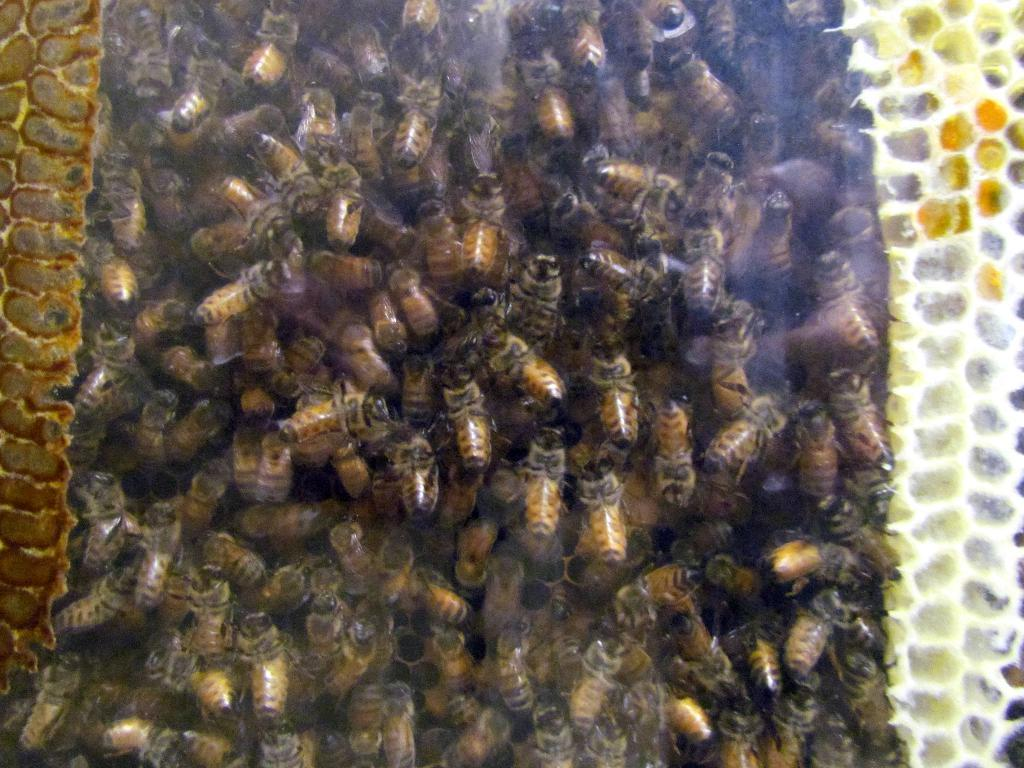What type of insects are present in the image? There are honey bees in the image. What color are the honey bees? The honey bees are brown in color. Where are the honey bees located in the image? The honey bees are in the middle of the image. What type of advertisement can be seen in the image? There is no advertisement present in the image; it features honey bees. What health benefits can be gained from the honey bees in the image? The image does not provide information about the health benefits of honey bees; it simply shows their presence. 